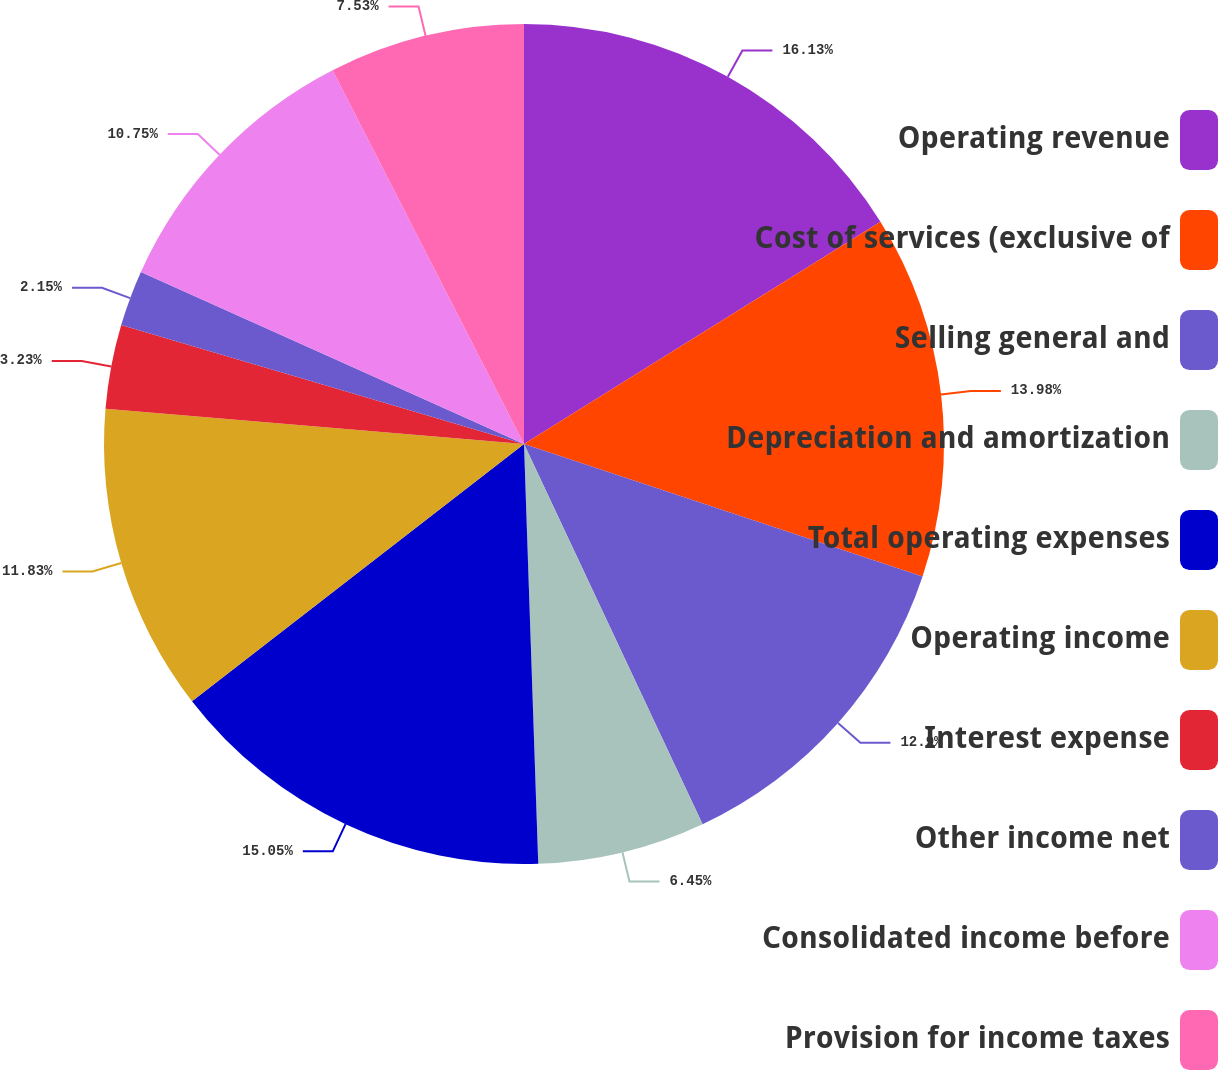<chart> <loc_0><loc_0><loc_500><loc_500><pie_chart><fcel>Operating revenue<fcel>Cost of services (exclusive of<fcel>Selling general and<fcel>Depreciation and amortization<fcel>Total operating expenses<fcel>Operating income<fcel>Interest expense<fcel>Other income net<fcel>Consolidated income before<fcel>Provision for income taxes<nl><fcel>16.13%<fcel>13.98%<fcel>12.9%<fcel>6.45%<fcel>15.05%<fcel>11.83%<fcel>3.23%<fcel>2.15%<fcel>10.75%<fcel>7.53%<nl></chart> 